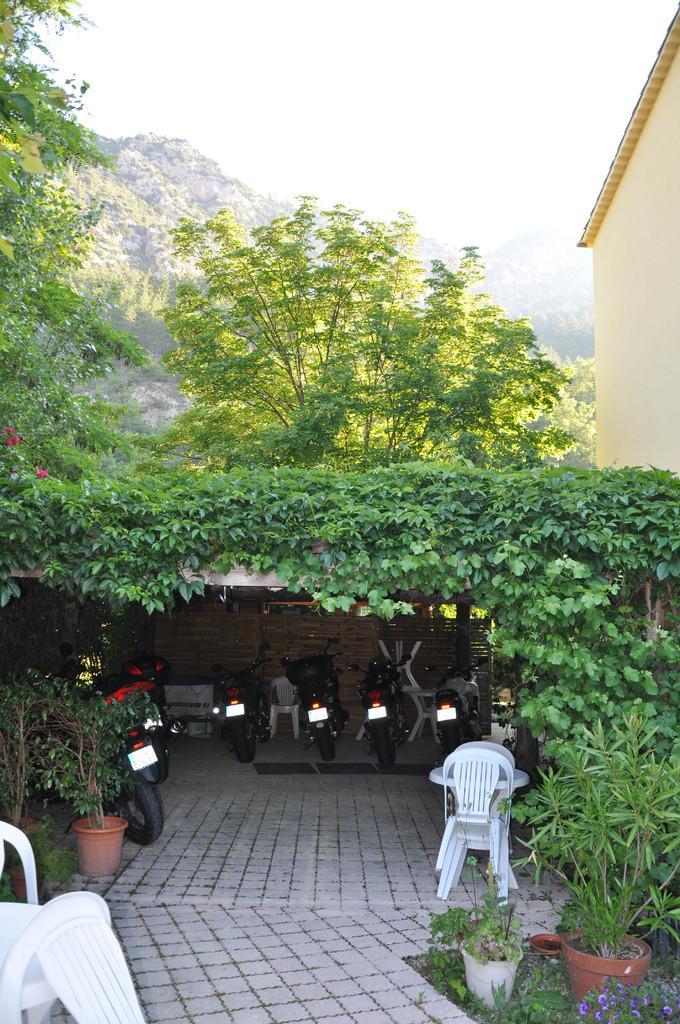How would you summarize this image in a sentence or two? Here we can see a a group of motorcycles on the ground, and here are the trees, and here are the flower pots,and here are the chairs, and at above here is the sky. 